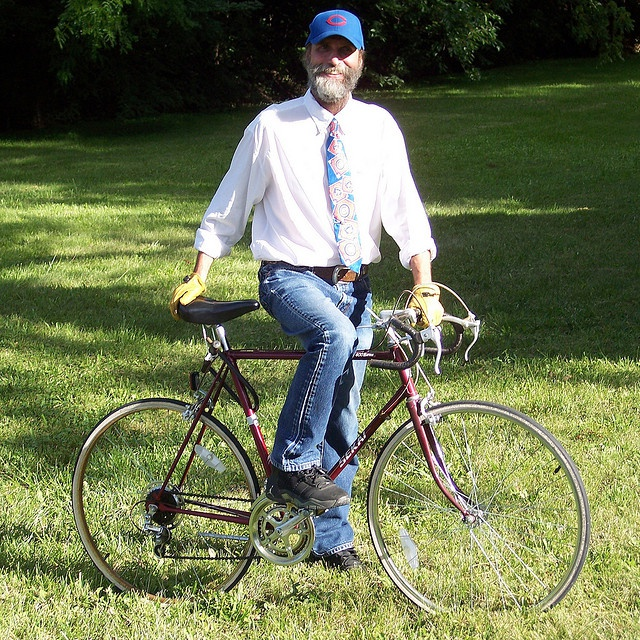Describe the objects in this image and their specific colors. I can see bicycle in black, olive, darkgreen, and khaki tones, people in black, white, darkgray, and navy tones, and tie in black, white, lightblue, and pink tones in this image. 